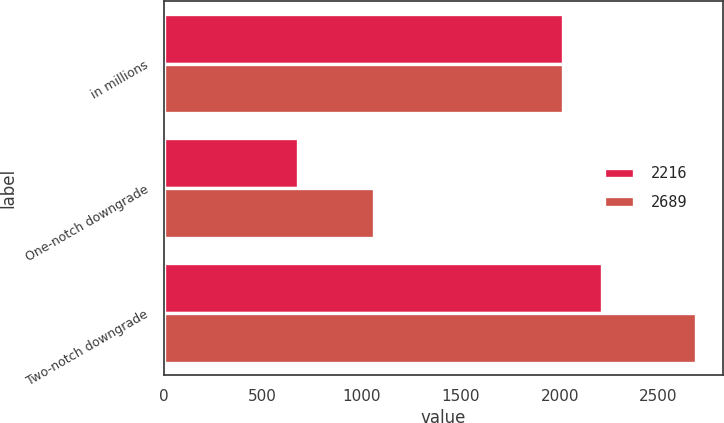Convert chart. <chart><loc_0><loc_0><loc_500><loc_500><stacked_bar_chart><ecel><fcel>in millions<fcel>One-notch downgrade<fcel>Two-notch downgrade<nl><fcel>2216<fcel>2016<fcel>677<fcel>2216<nl><fcel>2689<fcel>2015<fcel>1061<fcel>2689<nl></chart> 